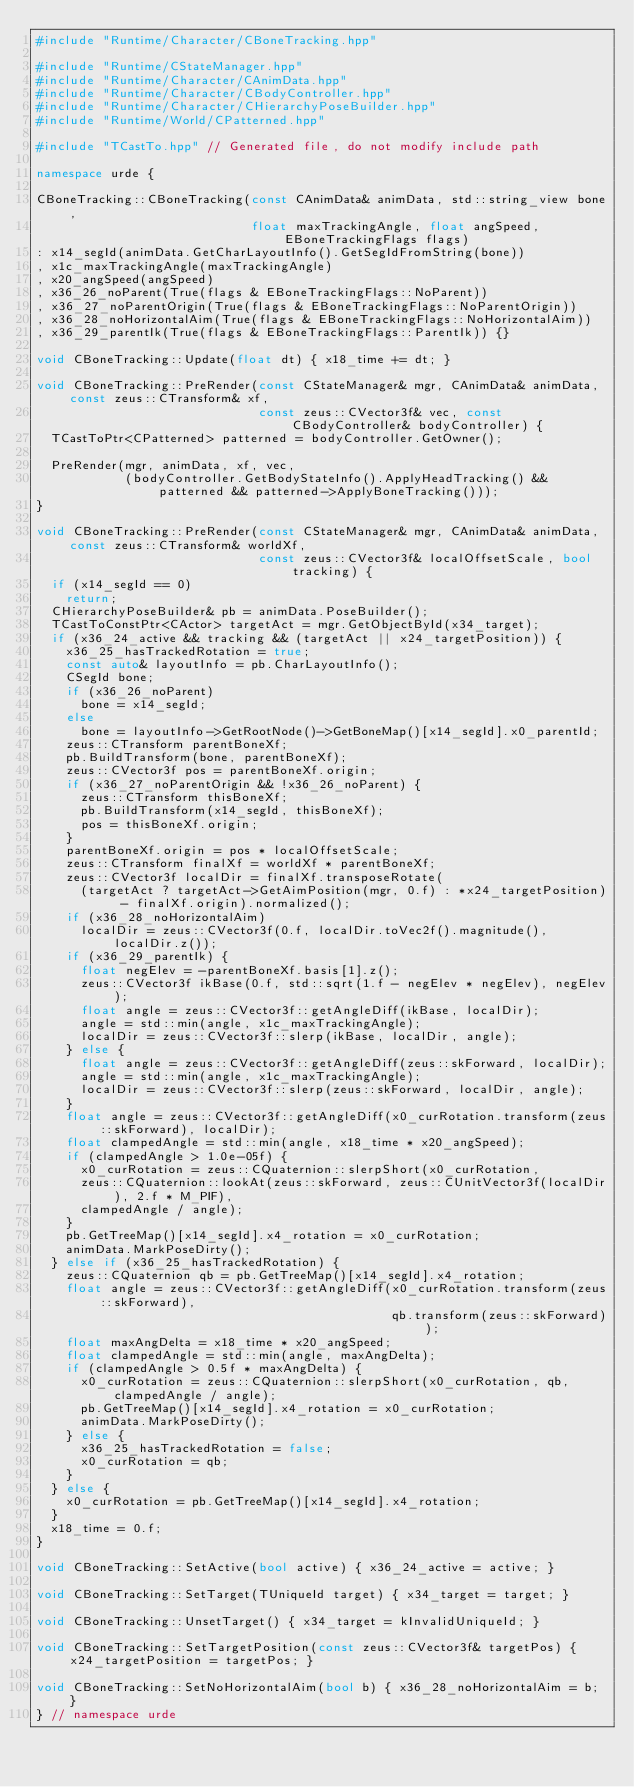Convert code to text. <code><loc_0><loc_0><loc_500><loc_500><_C++_>#include "Runtime/Character/CBoneTracking.hpp"

#include "Runtime/CStateManager.hpp"
#include "Runtime/Character/CAnimData.hpp"
#include "Runtime/Character/CBodyController.hpp"
#include "Runtime/Character/CHierarchyPoseBuilder.hpp"
#include "Runtime/World/CPatterned.hpp"

#include "TCastTo.hpp" // Generated file, do not modify include path

namespace urde {

CBoneTracking::CBoneTracking(const CAnimData& animData, std::string_view bone,
                             float maxTrackingAngle, float angSpeed, EBoneTrackingFlags flags)
: x14_segId(animData.GetCharLayoutInfo().GetSegIdFromString(bone))
, x1c_maxTrackingAngle(maxTrackingAngle)
, x20_angSpeed(angSpeed)
, x36_26_noParent(True(flags & EBoneTrackingFlags::NoParent))
, x36_27_noParentOrigin(True(flags & EBoneTrackingFlags::NoParentOrigin))
, x36_28_noHorizontalAim(True(flags & EBoneTrackingFlags::NoHorizontalAim))
, x36_29_parentIk(True(flags & EBoneTrackingFlags::ParentIk)) {}

void CBoneTracking::Update(float dt) { x18_time += dt; }

void CBoneTracking::PreRender(const CStateManager& mgr, CAnimData& animData, const zeus::CTransform& xf,
                              const zeus::CVector3f& vec, const CBodyController& bodyController) {
  TCastToPtr<CPatterned> patterned = bodyController.GetOwner();

  PreRender(mgr, animData, xf, vec,
            (bodyController.GetBodyStateInfo().ApplyHeadTracking() && patterned && patterned->ApplyBoneTracking()));
}

void CBoneTracking::PreRender(const CStateManager& mgr, CAnimData& animData, const zeus::CTransform& worldXf,
                              const zeus::CVector3f& localOffsetScale, bool tracking) {
  if (x14_segId == 0)
    return;
  CHierarchyPoseBuilder& pb = animData.PoseBuilder();
  TCastToConstPtr<CActor> targetAct = mgr.GetObjectById(x34_target);
  if (x36_24_active && tracking && (targetAct || x24_targetPosition)) {
    x36_25_hasTrackedRotation = true;
    const auto& layoutInfo = pb.CharLayoutInfo();
    CSegId bone;
    if (x36_26_noParent)
      bone = x14_segId;
    else
      bone = layoutInfo->GetRootNode()->GetBoneMap()[x14_segId].x0_parentId;
    zeus::CTransform parentBoneXf;
    pb.BuildTransform(bone, parentBoneXf);
    zeus::CVector3f pos = parentBoneXf.origin;
    if (x36_27_noParentOrigin && !x36_26_noParent) {
      zeus::CTransform thisBoneXf;
      pb.BuildTransform(x14_segId, thisBoneXf);
      pos = thisBoneXf.origin;
    }
    parentBoneXf.origin = pos * localOffsetScale;
    zeus::CTransform finalXf = worldXf * parentBoneXf;
    zeus::CVector3f localDir = finalXf.transposeRotate(
      (targetAct ? targetAct->GetAimPosition(mgr, 0.f) : *x24_targetPosition) - finalXf.origin).normalized();
    if (x36_28_noHorizontalAim)
      localDir = zeus::CVector3f(0.f, localDir.toVec2f().magnitude(), localDir.z());
    if (x36_29_parentIk) {
      float negElev = -parentBoneXf.basis[1].z();
      zeus::CVector3f ikBase(0.f, std::sqrt(1.f - negElev * negElev), negElev);
      float angle = zeus::CVector3f::getAngleDiff(ikBase, localDir);
      angle = std::min(angle, x1c_maxTrackingAngle);
      localDir = zeus::CVector3f::slerp(ikBase, localDir, angle);
    } else {
      float angle = zeus::CVector3f::getAngleDiff(zeus::skForward, localDir);
      angle = std::min(angle, x1c_maxTrackingAngle);
      localDir = zeus::CVector3f::slerp(zeus::skForward, localDir, angle);
    }
    float angle = zeus::CVector3f::getAngleDiff(x0_curRotation.transform(zeus::skForward), localDir);
    float clampedAngle = std::min(angle, x18_time * x20_angSpeed);
    if (clampedAngle > 1.0e-05f) {
      x0_curRotation = zeus::CQuaternion::slerpShort(x0_curRotation,
      zeus::CQuaternion::lookAt(zeus::skForward, zeus::CUnitVector3f(localDir), 2.f * M_PIF),
      clampedAngle / angle);
    }
    pb.GetTreeMap()[x14_segId].x4_rotation = x0_curRotation;
    animData.MarkPoseDirty();
  } else if (x36_25_hasTrackedRotation) {
    zeus::CQuaternion qb = pb.GetTreeMap()[x14_segId].x4_rotation;
    float angle = zeus::CVector3f::getAngleDiff(x0_curRotation.transform(zeus::skForward),
                                                qb.transform(zeus::skForward));
    float maxAngDelta = x18_time * x20_angSpeed;
    float clampedAngle = std::min(angle, maxAngDelta);
    if (clampedAngle > 0.5f * maxAngDelta) {
      x0_curRotation = zeus::CQuaternion::slerpShort(x0_curRotation, qb, clampedAngle / angle);
      pb.GetTreeMap()[x14_segId].x4_rotation = x0_curRotation;
      animData.MarkPoseDirty();
    } else {
      x36_25_hasTrackedRotation = false;
      x0_curRotation = qb;
    }
  } else {
    x0_curRotation = pb.GetTreeMap()[x14_segId].x4_rotation;
  }
  x18_time = 0.f;
}

void CBoneTracking::SetActive(bool active) { x36_24_active = active; }

void CBoneTracking::SetTarget(TUniqueId target) { x34_target = target; }

void CBoneTracking::UnsetTarget() { x34_target = kInvalidUniqueId; }

void CBoneTracking::SetTargetPosition(const zeus::CVector3f& targetPos) { x24_targetPosition = targetPos; }

void CBoneTracking::SetNoHorizontalAim(bool b) { x36_28_noHorizontalAim = b; }
} // namespace urde</code> 